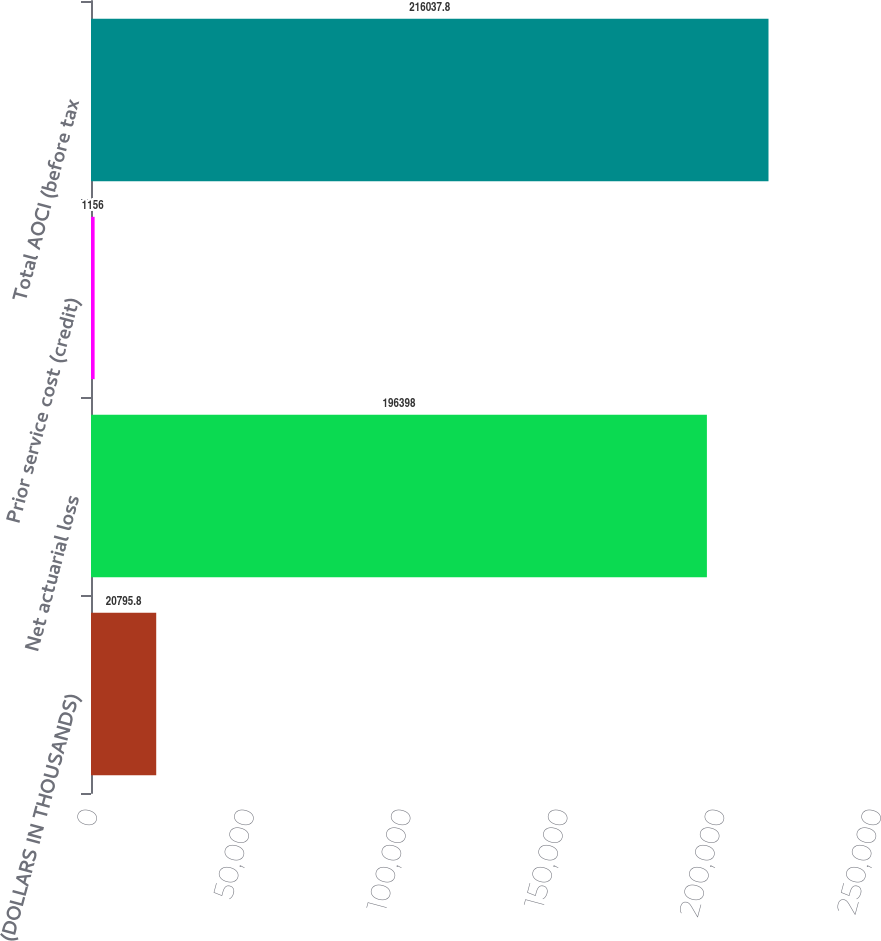Convert chart to OTSL. <chart><loc_0><loc_0><loc_500><loc_500><bar_chart><fcel>(DOLLARS IN THOUSANDS)<fcel>Net actuarial loss<fcel>Prior service cost (credit)<fcel>Total AOCI (before tax<nl><fcel>20795.8<fcel>196398<fcel>1156<fcel>216038<nl></chart> 